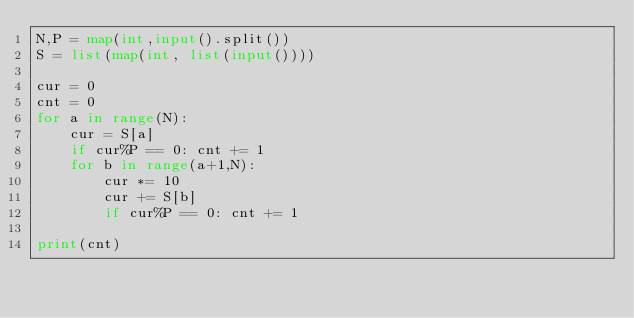<code> <loc_0><loc_0><loc_500><loc_500><_Python_>N,P = map(int,input().split())
S = list(map(int, list(input())))

cur = 0
cnt = 0
for a in range(N):
    cur = S[a]
    if cur%P == 0: cnt += 1
    for b in range(a+1,N):
        cur *= 10
        cur += S[b]
        if cur%P == 0: cnt += 1

print(cnt)</code> 